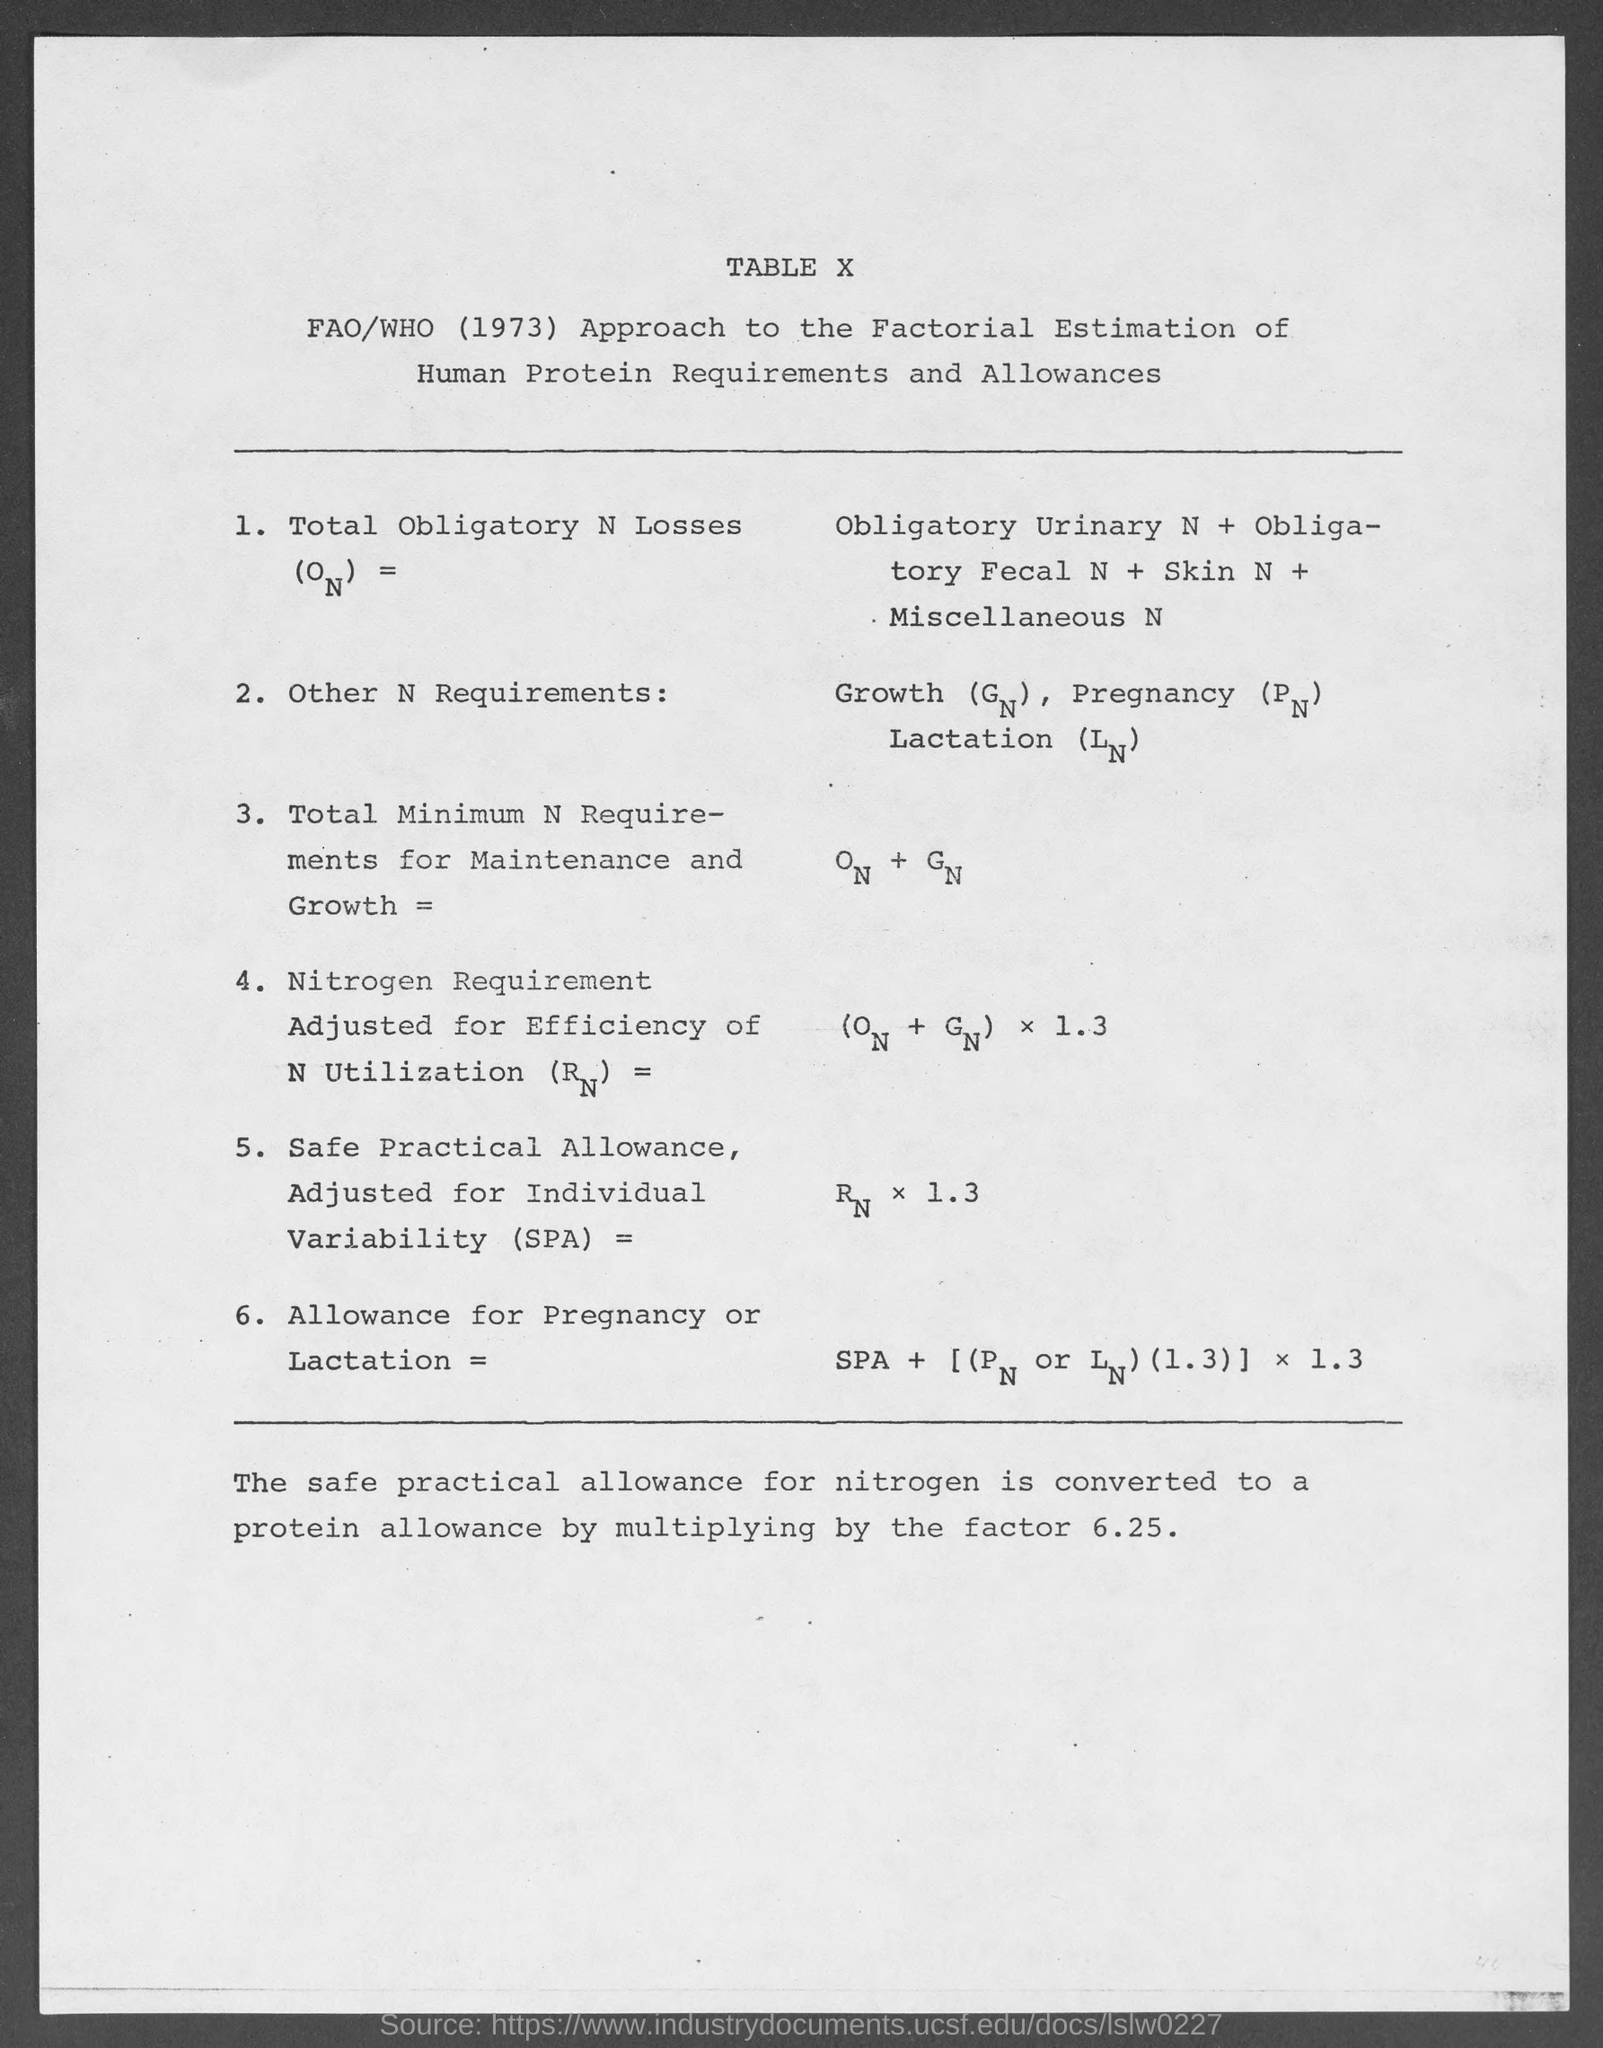List a handful of essential elements in this visual. What is the table number? X..." is a question that requires a response to provide the specific table number being referred to. 